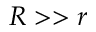<formula> <loc_0><loc_0><loc_500><loc_500>R > > r</formula> 